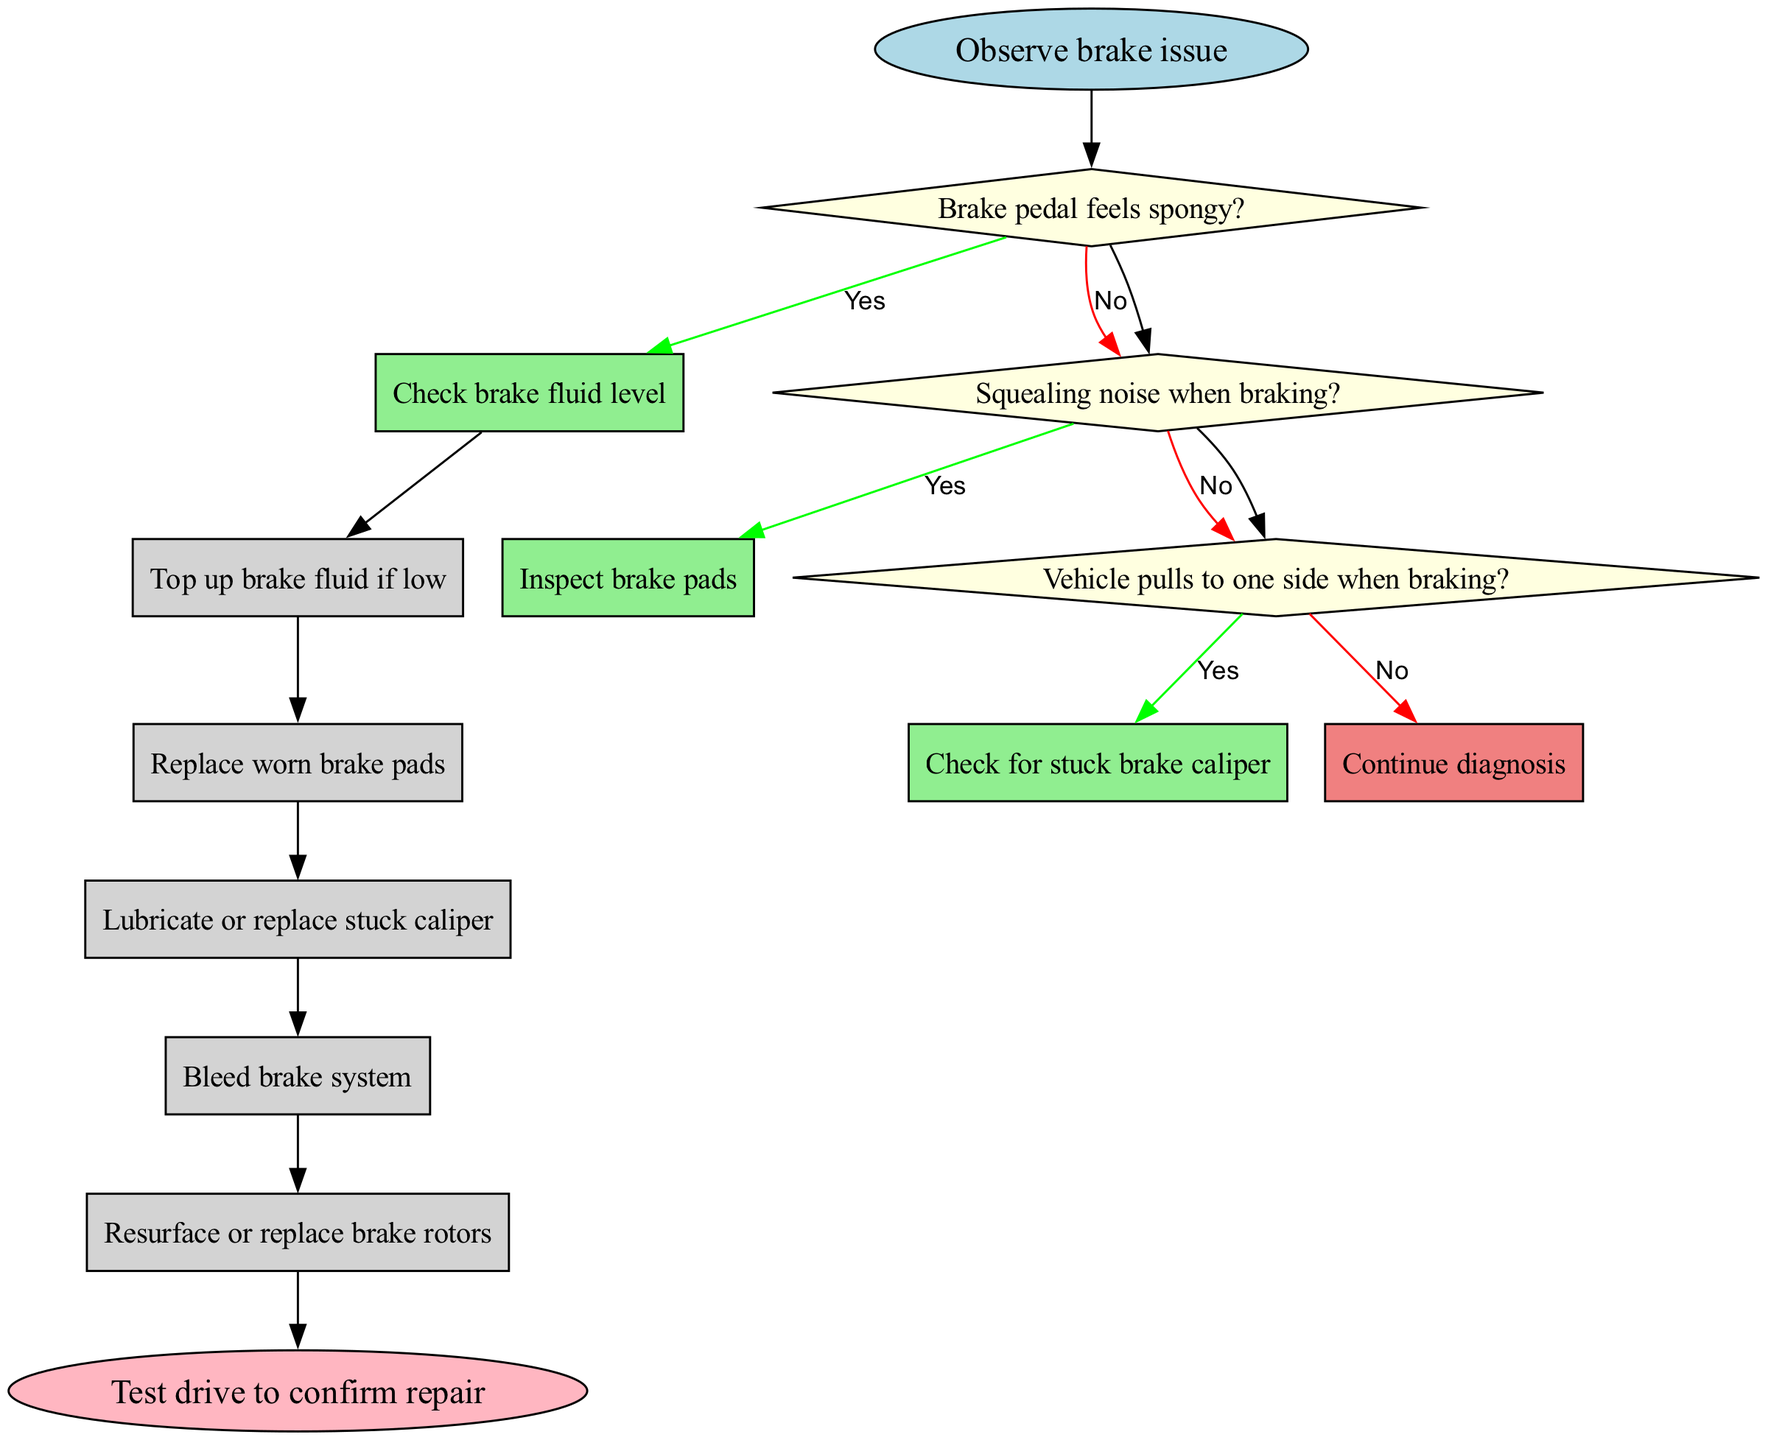What is the first step in diagnosing faulty brakes? The diagram indicates that the first step is to "Observe brake issue," which serves as the starting point for the diagnosis process.
Answer: Observe brake issue How many decision nodes are in the diagram? By counting the nodes labeled as decision points, we find there are three decision nodes that represent questions about brake symptoms.
Answer: 3 What action follows if the brake pedal feels spongy? Based on the flow, if the brake pedal feels spongy, the next action is to "Check brake fluid level" to assess the state of the brake fluid.
Answer: Check brake fluid level What is the terminal action before concluding the diagnosis? The diagram ends with the action "Test drive to confirm repair," which indicates the final step after making repairs to ensure they are effective.
Answer: Test drive to confirm repair If the vehicle pulls to one side when braking, what should be checked? The flowchart specifies that if the vehicle pulls to one side, the next step is to "Check for stuck brake caliper," targeting a common cause of this symptom.
Answer: Check for stuck brake caliper Which action follows replacing the worn brake pads? After replacing worn brake pads, the next action indicated in the flow is to "Bleed brake system," which is necessary to remove air from the braking system.
Answer: Bleed brake system What type of node connects actions in this diagram? The actions in this diagram are connected by rectangular nodes that represent the various steps that need to be performed during the brake repair process.
Answer: Rectangle What happens if the brake pads are found to be fine? If the brake pads are not the issue, the flow leads to continuing the diagnosis process, implying further investigation into other symptoms.
Answer: Continue diagnosis What is the color of the decision nodes in the diagram? The decision nodes are colored light yellow, which is a consistent design choice made to differentiate them from other types of nodes in the diagram.
Answer: Light yellow 